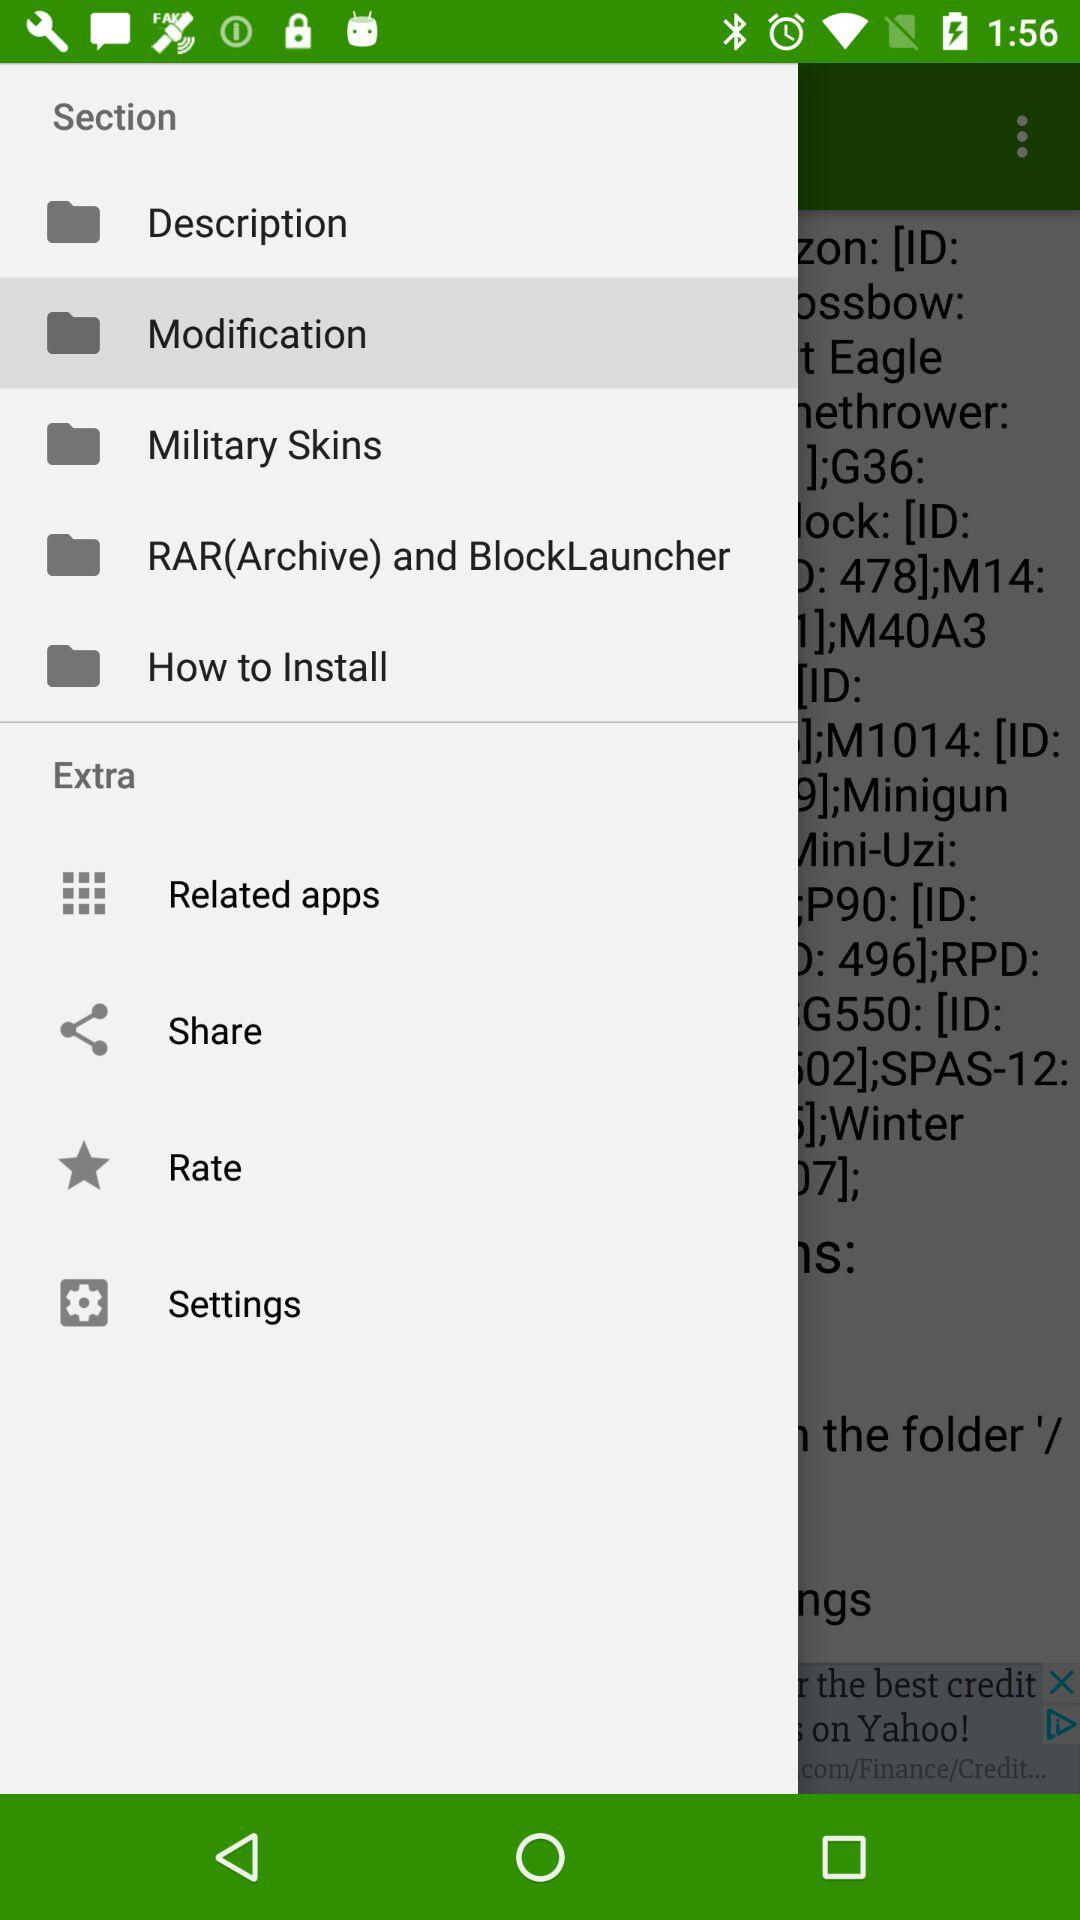Which is the selected "Section"? The selected "Section" is "Modification". 